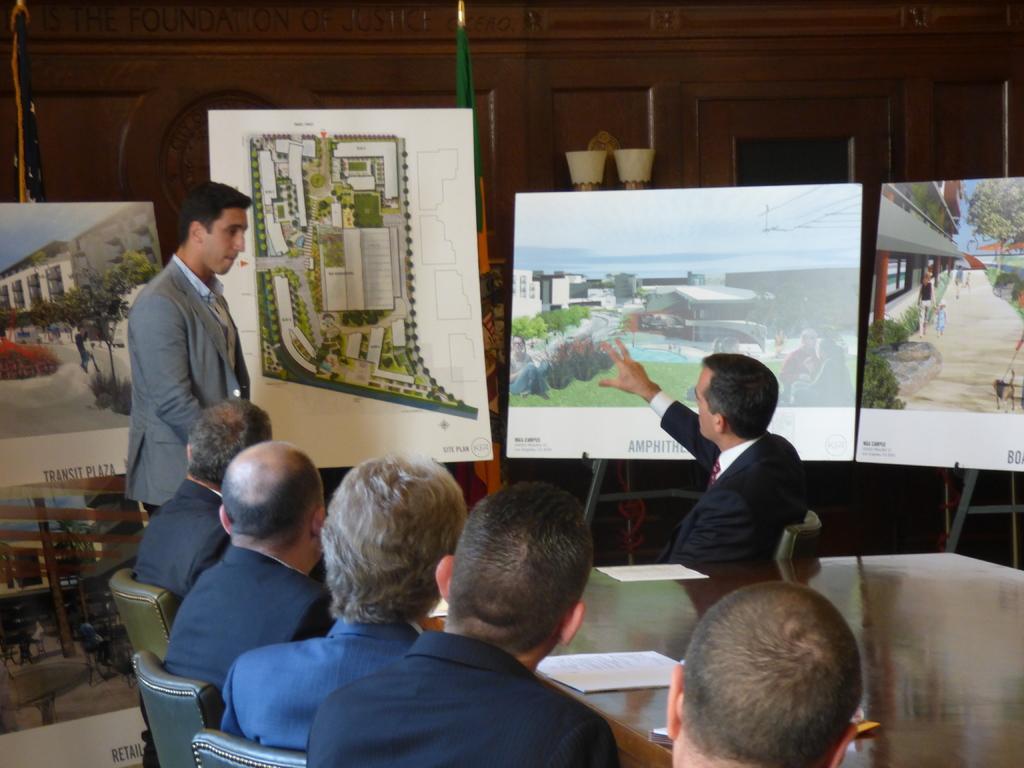Can you describe this image briefly? In this image i can see a group of people are sitting on a chair in front of a table. A man is standing on the floor. I can see there are few paint boards on the table. 